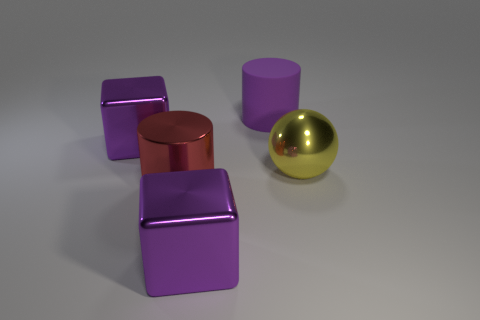There is a yellow ball that is made of the same material as the large red thing; what size is it?
Give a very brief answer. Large. How many spheres have the same color as the shiny cylinder?
Make the answer very short. 0. How many big objects are blue matte spheres or purple cylinders?
Ensure brevity in your answer.  1. Is there a large sphere that has the same material as the large red cylinder?
Ensure brevity in your answer.  Yes. What material is the purple object that is in front of the yellow shiny ball?
Your answer should be very brief. Metal. There is a cylinder that is to the left of the big purple rubber cylinder; is its color the same as the metallic thing that is behind the sphere?
Keep it short and to the point. No. There is another cylinder that is the same size as the purple cylinder; what is its color?
Ensure brevity in your answer.  Red. What number of other things are the same shape as the large purple rubber thing?
Provide a short and direct response. 1. There is a block in front of the large yellow ball; what size is it?
Your answer should be very brief. Large. There is a purple cube behind the large shiny cylinder; what number of big metallic balls are behind it?
Provide a short and direct response. 0. 